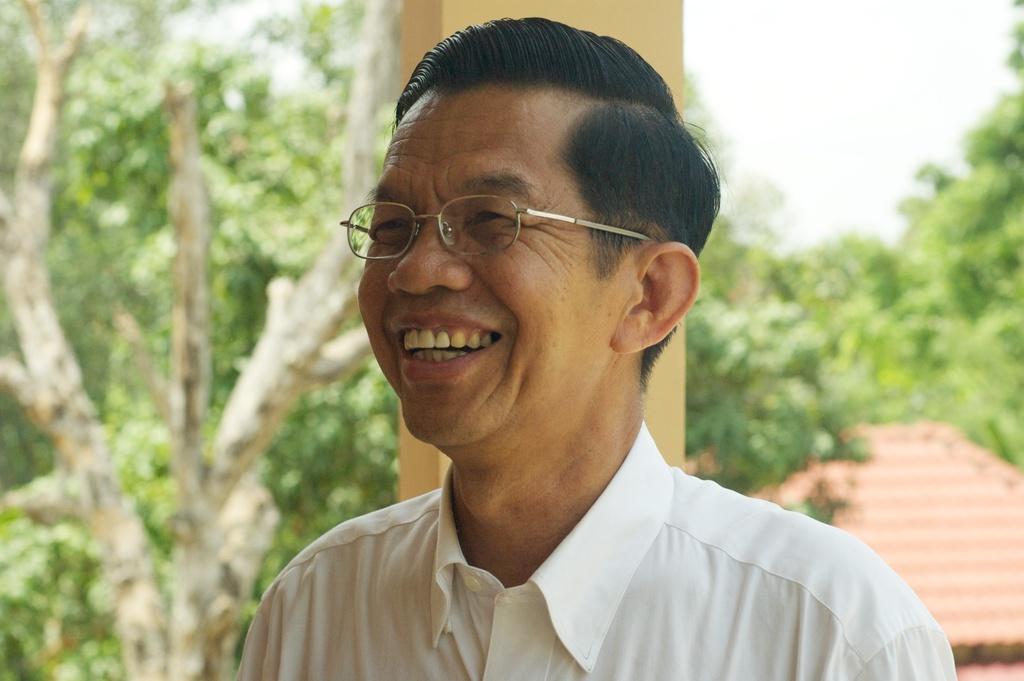Describe this image in one or two sentences. In this picture we can see man wearing a white color shirt, specs, smiling and looking straight in the image. Behind we can see some tree and shed house. 